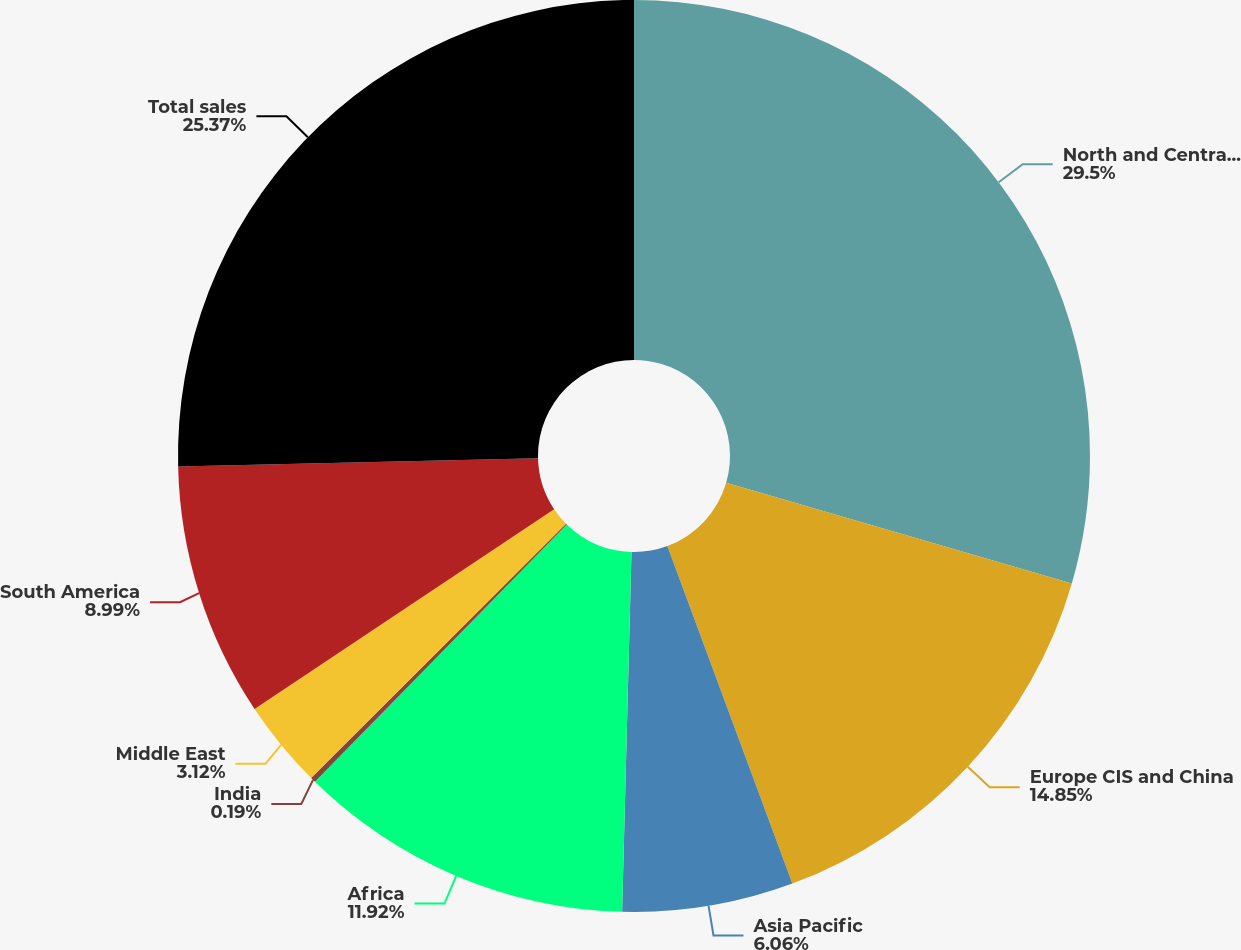Convert chart. <chart><loc_0><loc_0><loc_500><loc_500><pie_chart><fcel>North and Central America<fcel>Europe CIS and China<fcel>Asia Pacific<fcel>Africa<fcel>India<fcel>Middle East<fcel>South America<fcel>Total sales<nl><fcel>29.51%<fcel>14.85%<fcel>6.06%<fcel>11.92%<fcel>0.19%<fcel>3.12%<fcel>8.99%<fcel>25.37%<nl></chart> 